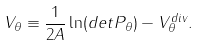Convert formula to latex. <formula><loc_0><loc_0><loc_500><loc_500>V _ { \theta } \equiv \frac { 1 } { 2 A } \ln ( d e t P _ { \theta } ) - V _ { \theta } ^ { d i v } .</formula> 